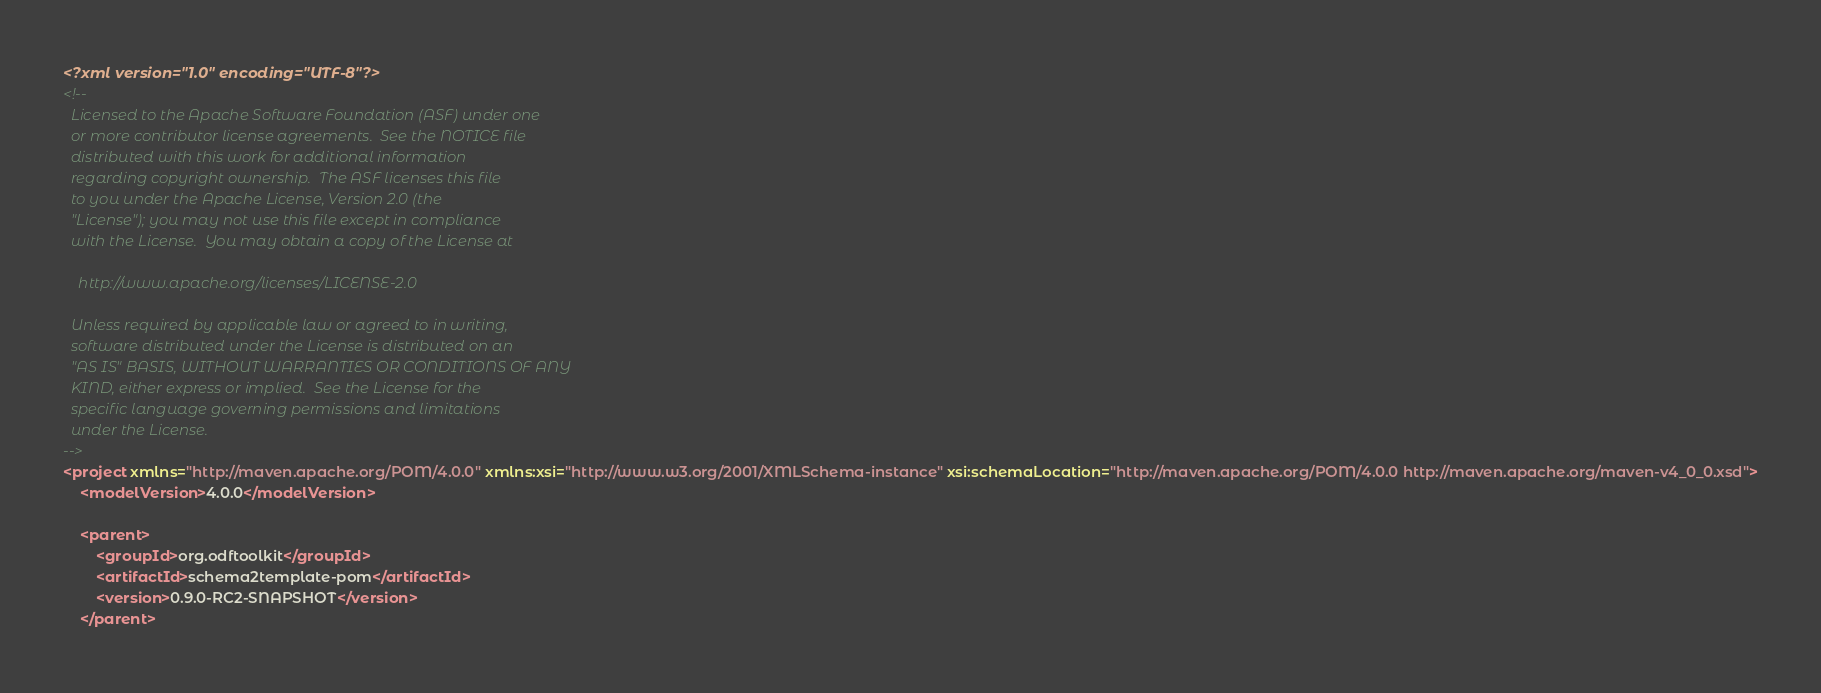Convert code to text. <code><loc_0><loc_0><loc_500><loc_500><_XML_><?xml version="1.0" encoding="UTF-8"?>
<!--
  Licensed to the Apache Software Foundation (ASF) under one
  or more contributor license agreements.  See the NOTICE file
  distributed with this work for additional information
  regarding copyright ownership.  The ASF licenses this file
  to you under the Apache License, Version 2.0 (the
  "License"); you may not use this file except in compliance
  with the License.  You may obtain a copy of the License at

    http://www.apache.org/licenses/LICENSE-2.0

  Unless required by applicable law or agreed to in writing,
  software distributed under the License is distributed on an
  "AS IS" BASIS, WITHOUT WARRANTIES OR CONDITIONS OF ANY
  KIND, either express or implied.  See the License for the
  specific language governing permissions and limitations
  under the License.
-->
<project xmlns="http://maven.apache.org/POM/4.0.0" xmlns:xsi="http://www.w3.org/2001/XMLSchema-instance" xsi:schemaLocation="http://maven.apache.org/POM/4.0.0 http://maven.apache.org/maven-v4_0_0.xsd">
    <modelVersion>4.0.0</modelVersion>

    <parent>
        <groupId>org.odftoolkit</groupId>
        <artifactId>schema2template-pom</artifactId>
        <version>0.9.0-RC2-SNAPSHOT</version>
    </parent>
</code> 